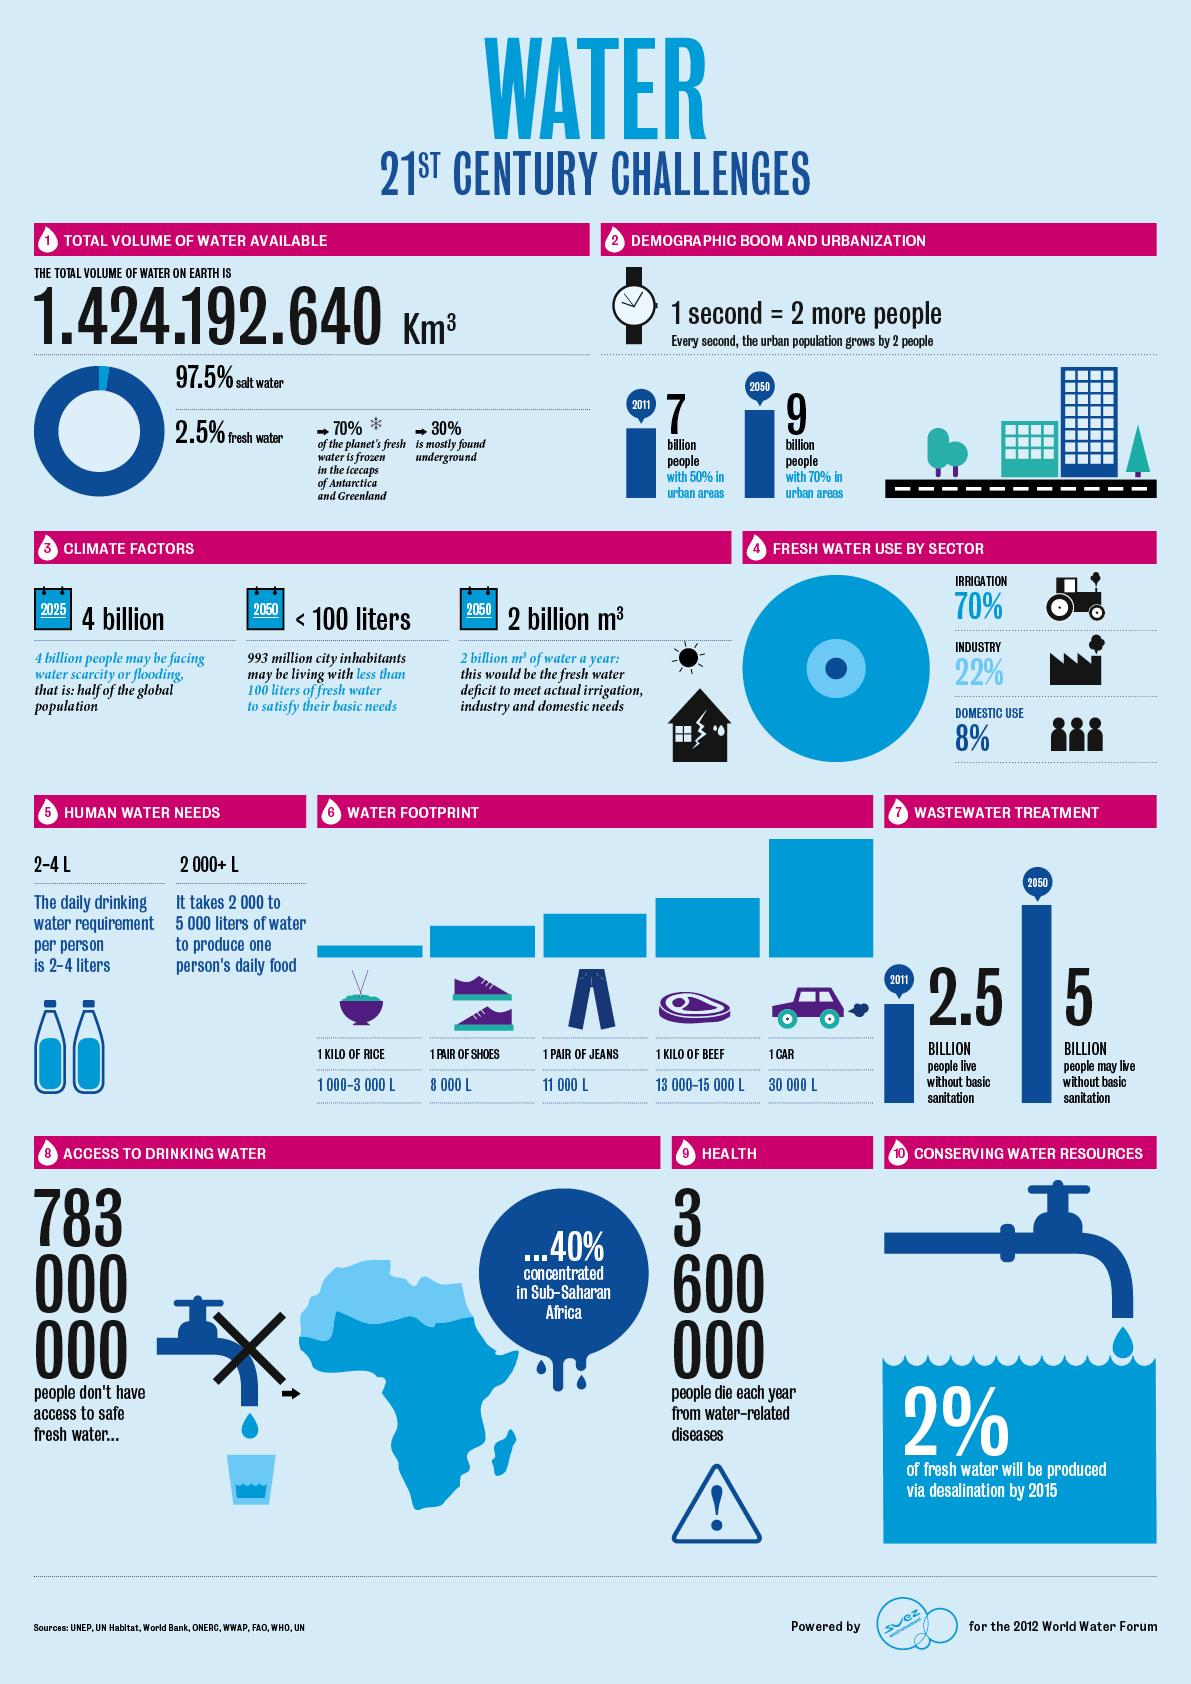Point out several critical features in this image. By the year 2015, it is projected that only 2% of the world's fresh water supply will be produced through the process of desalination. By 2025, approximately 4 billion people are expected to be facing water scarcity or flooding due to the impacts of climate change and other factors. In the 21st century, approximately 70% of fresh water is used for irrigation purposes. In the 21st century, approximately 22% of fresh water is used for industrial purposes. The domestic sector has had the lowest percentage of water consumption in the 21st century. 